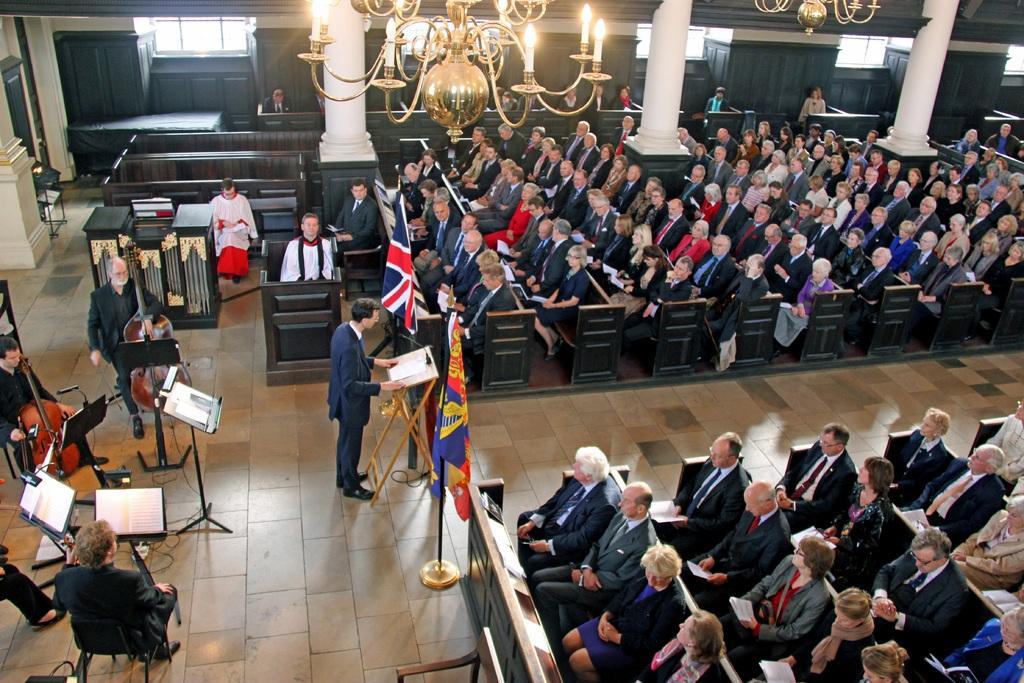Please provide a concise description of this image. In this image we can see people sitting and some of them are standing. There are podiums and stands. We can see books placed on the stands. There are musical instruments. In the center we can see a flag. At the top there are chandeliers. In the background there are windows and pillars. 